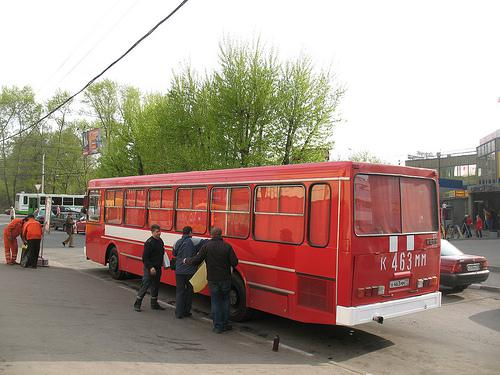Question: who is wearing orange?
Choices:
A. The women.
B. The children.
C. The men.
D. The football team.
Answer with the letter. Answer: C Question: why is it so bright?
Choices:
A. Sunny.
B. Lightbulb.
C. Lantern.
D. Flashlight.
Answer with the letter. Answer: A Question: what says 463?
Choices:
A. Street sign.
B. Bus sign.
C. Storefront address.
D. Interstate sign.
Answer with the letter. Answer: B Question: where was the photo taken?
Choices:
A. In a small town.
B. In front of the Apple store.
C. In Central Park.
D. On the street.
Answer with the letter. Answer: D 